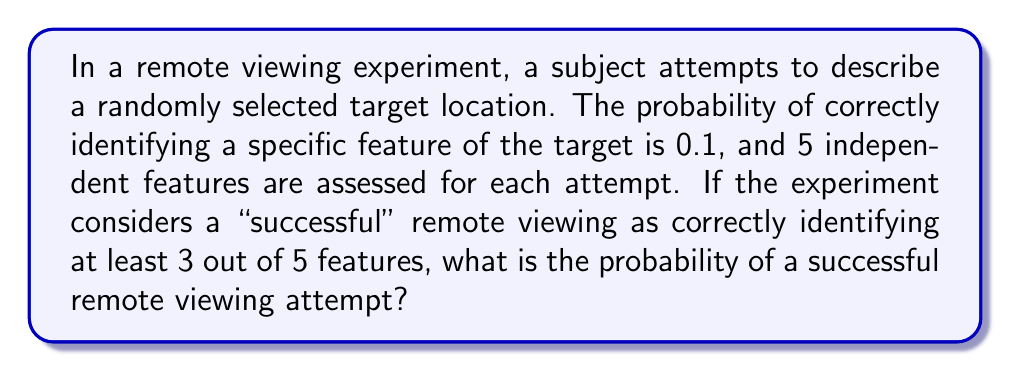Solve this math problem. To solve this problem, we need to use the binomial probability distribution, as we are dealing with a fixed number of independent trials (5 features) with a constant probability of success for each trial (0.1).

Let's approach this step-by-step:

1) The probability of success for each feature is $p = 0.1$, and the probability of failure is $q = 1 - p = 0.9$.

2) We need to calculate the probability of correctly identifying 3, 4, or 5 features out of 5.

3) The binomial probability formula for exactly $k$ successes in $n$ trials is:

   $P(X = k) = \binom{n}{k} p^k q^{n-k}$

4) We need to sum the probabilities for $k = 3$, $k = 4$, and $k = 5$:

   $P(\text{success}) = P(X = 3) + P(X = 4) + P(X = 5)$

5) Let's calculate each term:

   $P(X = 3) = \binom{5}{3} (0.1)^3 (0.9)^2 = 10 \cdot 0.001 \cdot 0.81 = 0.0081$

   $P(X = 4) = \binom{5}{4} (0.1)^4 (0.9)^1 = 5 \cdot 0.0001 \cdot 0.9 = 0.00045$

   $P(X = 5) = \binom{5}{5} (0.1)^5 (0.9)^0 = 1 \cdot 0.00001 \cdot 1 = 0.00001$

6) Sum these probabilities:

   $P(\text{success}) = 0.0081 + 0.00045 + 0.00001 = 0.00856$

Therefore, the probability of a successful remote viewing attempt is approximately 0.00856 or 0.856%.
Answer: 0.00856 